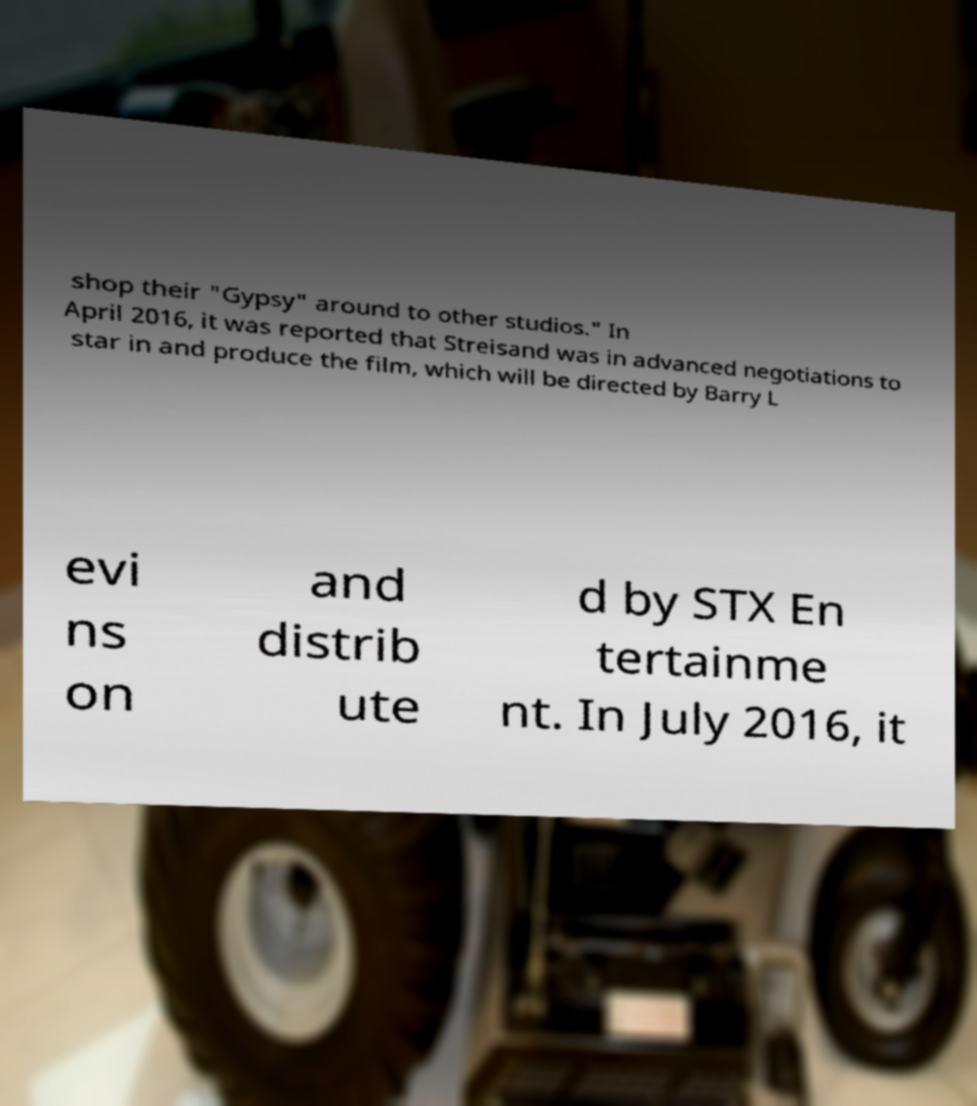What messages or text are displayed in this image? I need them in a readable, typed format. shop their "Gypsy" around to other studios." In April 2016, it was reported that Streisand was in advanced negotiations to star in and produce the film, which will be directed by Barry L evi ns on and distrib ute d by STX En tertainme nt. In July 2016, it 